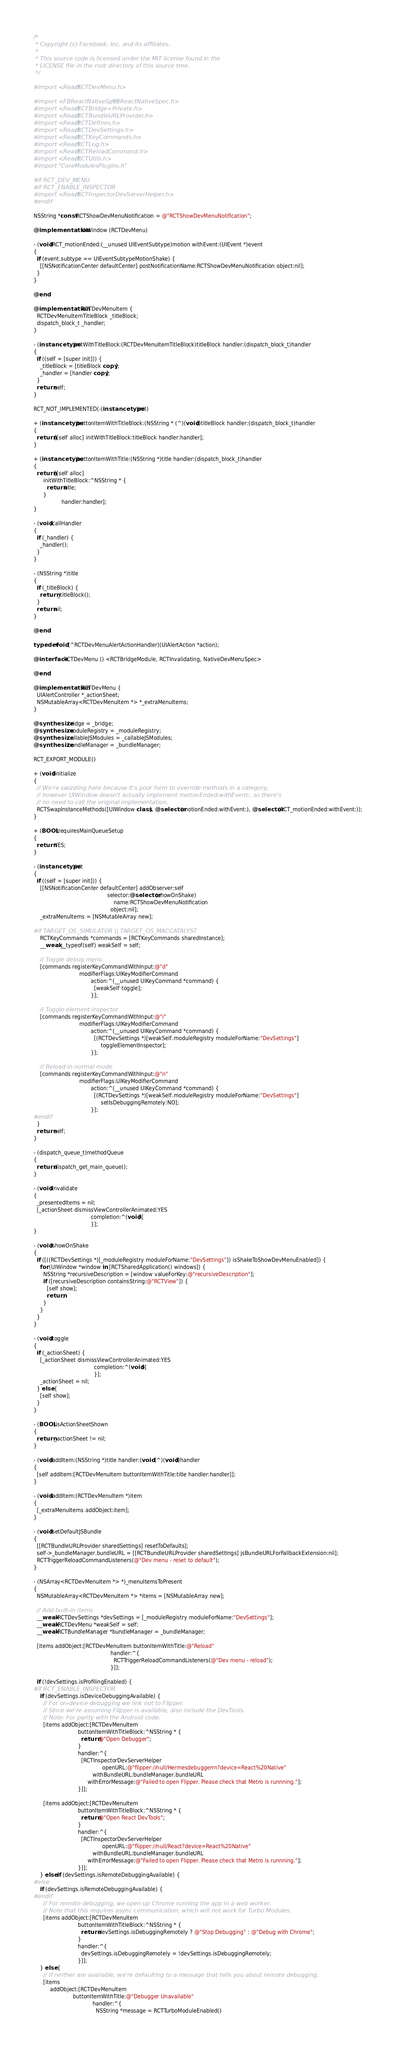Convert code to text. <code><loc_0><loc_0><loc_500><loc_500><_ObjectiveC_>/*
 * Copyright (c) Facebook, Inc. and its affiliates.
 *
 * This source code is licensed under the MIT license found in the
 * LICENSE file in the root directory of this source tree.
 */

#import <React/RCTDevMenu.h>

#import <FBReactNativeSpec/FBReactNativeSpec.h>
#import <React/RCTBridge+Private.h>
#import <React/RCTBundleURLProvider.h>
#import <React/RCTDefines.h>
#import <React/RCTDevSettings.h>
#import <React/RCTKeyCommands.h>
#import <React/RCTLog.h>
#import <React/RCTReloadCommand.h>
#import <React/RCTUtils.h>
#import "CoreModulesPlugins.h"

#if RCT_DEV_MENU
#if RCT_ENABLE_INSPECTOR
#import <React/RCTInspectorDevServerHelper.h>
#endif

NSString *const RCTShowDevMenuNotification = @"RCTShowDevMenuNotification";

@implementation UIWindow (RCTDevMenu)

- (void)RCT_motionEnded:(__unused UIEventSubtype)motion withEvent:(UIEvent *)event
{
  if (event.subtype == UIEventSubtypeMotionShake) {
    [[NSNotificationCenter defaultCenter] postNotificationName:RCTShowDevMenuNotification object:nil];
  }
}

@end

@implementation RCTDevMenuItem {
  RCTDevMenuItemTitleBlock _titleBlock;
  dispatch_block_t _handler;
}

- (instancetype)initWithTitleBlock:(RCTDevMenuItemTitleBlock)titleBlock handler:(dispatch_block_t)handler
{
  if ((self = [super init])) {
    _titleBlock = [titleBlock copy];
    _handler = [handler copy];
  }
  return self;
}

RCT_NOT_IMPLEMENTED(-(instancetype)init)

+ (instancetype)buttonItemWithTitleBlock:(NSString * (^)(void))titleBlock handler:(dispatch_block_t)handler
{
  return [[self alloc] initWithTitleBlock:titleBlock handler:handler];
}

+ (instancetype)buttonItemWithTitle:(NSString *)title handler:(dispatch_block_t)handler
{
  return [[self alloc]
      initWithTitleBlock:^NSString * {
        return title;
      }
                 handler:handler];
}

- (void)callHandler
{
  if (_handler) {
    _handler();
  }
}

- (NSString *)title
{
  if (_titleBlock) {
    return _titleBlock();
  }
  return nil;
}

@end

typedef void (^RCTDevMenuAlertActionHandler)(UIAlertAction *action);

@interface RCTDevMenu () <RCTBridgeModule, RCTInvalidating, NativeDevMenuSpec>

@end

@implementation RCTDevMenu {
  UIAlertController *_actionSheet;
  NSMutableArray<RCTDevMenuItem *> *_extraMenuItems;
}

@synthesize bridge = _bridge;
@synthesize moduleRegistry = _moduleRegistry;
@synthesize callableJSModules = _callableJSModules;
@synthesize bundleManager = _bundleManager;

RCT_EXPORT_MODULE()

+ (void)initialize
{
  // We're swizzling here because it's poor form to override methods in a category,
  // however UIWindow doesn't actually implement motionEnded:withEvent:, so there's
  // no need to call the original implementation.
  RCTSwapInstanceMethods([UIWindow class], @selector(motionEnded:withEvent:), @selector(RCT_motionEnded:withEvent:));
}

+ (BOOL)requiresMainQueueSetup
{
  return YES;
}

- (instancetype)init
{
  if ((self = [super init])) {
    [[NSNotificationCenter defaultCenter] addObserver:self
                                             selector:@selector(showOnShake)
                                                 name:RCTShowDevMenuNotification
                                               object:nil];
    _extraMenuItems = [NSMutableArray new];

#if TARGET_OS_SIMULATOR || TARGET_OS_MACCATALYST
    RCTKeyCommands *commands = [RCTKeyCommands sharedInstance];
    __weak __typeof(self) weakSelf = self;

    // Toggle debug menu
    [commands registerKeyCommandWithInput:@"d"
                            modifierFlags:UIKeyModifierCommand
                                   action:^(__unused UIKeyCommand *command) {
                                     [weakSelf toggle];
                                   }];

    // Toggle element inspector
    [commands registerKeyCommandWithInput:@"i"
                            modifierFlags:UIKeyModifierCommand
                                   action:^(__unused UIKeyCommand *command) {
                                     [(RCTDevSettings *)[weakSelf.moduleRegistry moduleForName:"DevSettings"]
                                         toggleElementInspector];
                                   }];

    // Reload in normal mode
    [commands registerKeyCommandWithInput:@"n"
                            modifierFlags:UIKeyModifierCommand
                                   action:^(__unused UIKeyCommand *command) {
                                     [(RCTDevSettings *)[weakSelf.moduleRegistry moduleForName:"DevSettings"]
                                         setIsDebuggingRemotely:NO];
                                   }];
#endif
  }
  return self;
}

- (dispatch_queue_t)methodQueue
{
  return dispatch_get_main_queue();
}

- (void)invalidate
{
  _presentedItems = nil;
  [_actionSheet dismissViewControllerAnimated:YES
                                   completion:^(void){
                                   }];
}

- (void)showOnShake
{
  if ([((RCTDevSettings *)[_moduleRegistry moduleForName:"DevSettings"]) isShakeToShowDevMenuEnabled]) {
    for (UIWindow *window in [RCTSharedApplication() windows]) {
      NSString *recursiveDescription = [window valueForKey:@"recursiveDescription"];
      if ([recursiveDescription containsString:@"RCTView"]) {
        [self show];
        return;
      }
    }
  }
}

- (void)toggle
{
  if (_actionSheet) {
    [_actionSheet dismissViewControllerAnimated:YES
                                     completion:^(void){
                                     }];
    _actionSheet = nil;
  } else {
    [self show];
  }
}

- (BOOL)isActionSheetShown
{
  return _actionSheet != nil;
}

- (void)addItem:(NSString *)title handler:(void (^)(void))handler
{
  [self addItem:[RCTDevMenuItem buttonItemWithTitle:title handler:handler]];
}

- (void)addItem:(RCTDevMenuItem *)item
{
  [_extraMenuItems addObject:item];
}

- (void)setDefaultJSBundle
{
  [[RCTBundleURLProvider sharedSettings] resetToDefaults];
  self->_bundleManager.bundleURL = [[RCTBundleURLProvider sharedSettings] jsBundleURLForFallbackExtension:nil];
  RCTTriggerReloadCommandListeners(@"Dev menu - reset to default");
}

- (NSArray<RCTDevMenuItem *> *)_menuItemsToPresent
{
  NSMutableArray<RCTDevMenuItem *> *items = [NSMutableArray new];

  // Add built-in items
  __weak RCTDevSettings *devSettings = [_moduleRegistry moduleForName:"DevSettings"];
  __weak RCTDevMenu *weakSelf = self;
  __weak RCTBundleManager *bundleManager = _bundleManager;

  [items addObject:[RCTDevMenuItem buttonItemWithTitle:@"Reload"
                                               handler:^{
                                                 RCTTriggerReloadCommandListeners(@"Dev menu - reload");
                                               }]];

  if (!devSettings.isProfilingEnabled) {
#if RCT_ENABLE_INSPECTOR
    if (devSettings.isDeviceDebuggingAvailable) {
      // For on-device debugging we link out to Flipper.
      // Since we're assuming Flipper is available, also include the DevTools.
      // Note: For parity with the Android code.
      [items addObject:[RCTDevMenuItem
                           buttonItemWithTitleBlock:^NSString * {
                             return @"Open Debugger";
                           }
                           handler:^{
                             [RCTInspectorDevServerHelper
                                          openURL:@"flipper://null/Hermesdebuggerrn?device=React%20Native"
                                    withBundleURL:bundleManager.bundleURL
                                 withErrorMessage:@"Failed to open Flipper. Please check that Metro is runnning."];
                           }]];

      [items addObject:[RCTDevMenuItem
                           buttonItemWithTitleBlock:^NSString * {
                             return @"Open React DevTools";
                           }
                           handler:^{
                             [RCTInspectorDevServerHelper
                                          openURL:@"flipper://null/React?device=React%20Native"
                                    withBundleURL:bundleManager.bundleURL
                                 withErrorMessage:@"Failed to open Flipper. Please check that Metro is runnning."];
                           }]];
    } else if (devSettings.isRemoteDebuggingAvailable) {
#else
    if (devSettings.isRemoteDebuggingAvailable) {
#endif
      // For remote debugging, we open up Chrome running the app in a web worker.
      // Note that this requires async communication, which will not work for Turbo Modules.
      [items addObject:[RCTDevMenuItem
                           buttonItemWithTitleBlock:^NSString * {
                             return devSettings.isDebuggingRemotely ? @"Stop Debugging" : @"Debug with Chrome";
                           }
                           handler:^{
                             devSettings.isDebuggingRemotely = !devSettings.isDebuggingRemotely;
                           }]];
    } else {
      // If neither are available, we're defaulting to a message that tells you about remote debugging.
      [items
          addObject:[RCTDevMenuItem
                        buttonItemWithTitle:@"Debugger Unavailable"
                                    handler:^{
                                      NSString *message = RCTTurboModuleEnabled()</code> 